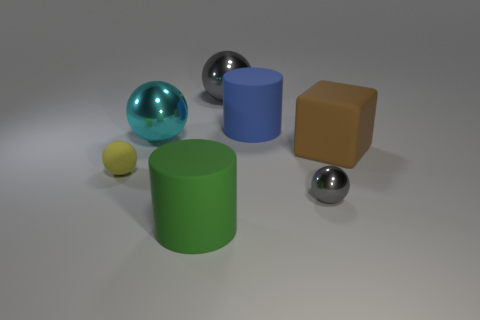Subtract all tiny yellow matte balls. How many balls are left? 3 Subtract all cyan cylinders. How many gray spheres are left? 2 Add 2 red cylinders. How many objects exist? 9 Subtract all cylinders. How many objects are left? 5 Subtract all cyan spheres. How many spheres are left? 3 Add 5 blue matte objects. How many blue matte objects are left? 6 Add 3 cubes. How many cubes exist? 4 Subtract 0 red cubes. How many objects are left? 7 Subtract all gray cubes. Subtract all green cylinders. How many cubes are left? 1 Subtract all large brown matte balls. Subtract all blue objects. How many objects are left? 6 